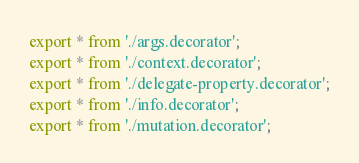<code> <loc_0><loc_0><loc_500><loc_500><_TypeScript_>export * from './args.decorator';
export * from './context.decorator';
export * from './delegate-property.decorator';
export * from './info.decorator';
export * from './mutation.decorator';</code> 